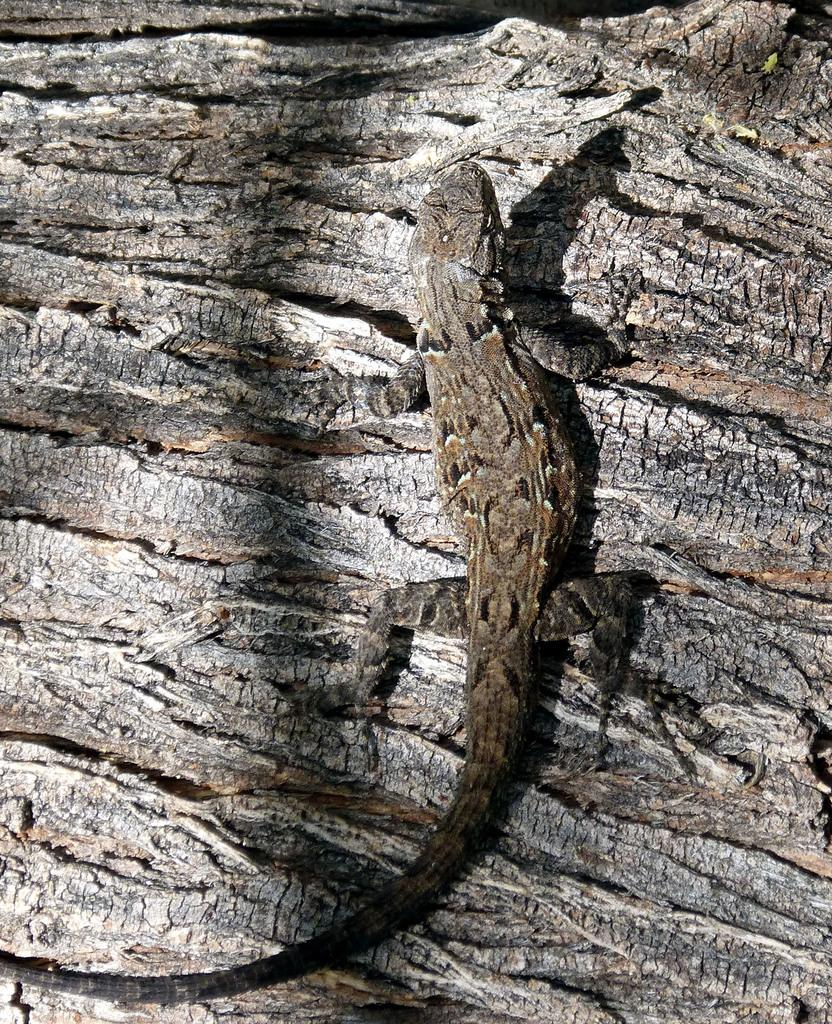What type of animal is in the image? There is a lizard in the image. Where is the lizard located? The lizard is on a tree trunk. What type of magic does the lizard perform in the image? There is no magic or any magical actions performed by the lizard in the image. 